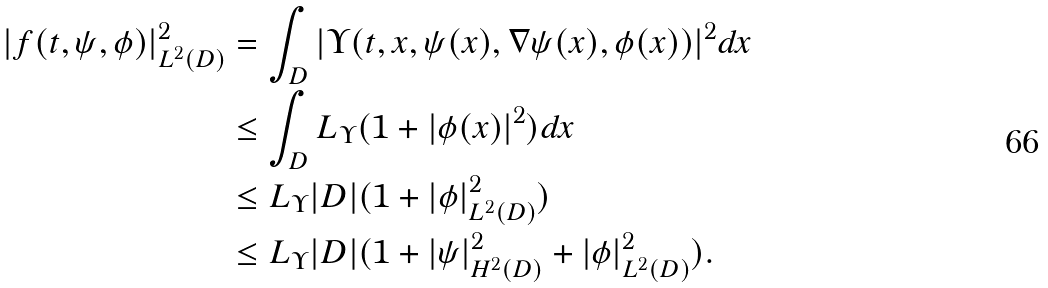<formula> <loc_0><loc_0><loc_500><loc_500>| f ( t , \psi , \phi ) | ^ { 2 } _ { L ^ { 2 } ( D ) } & = \int _ { D } | \Upsilon ( t , x , \psi ( x ) , \nabla \psi ( x ) , \phi ( x ) ) | ^ { 2 } d x \\ & \leq \int _ { D } L _ { \Upsilon } ( 1 + | \phi ( x ) | ^ { 2 } ) d x \\ & \leq L _ { \Upsilon } | D | ( 1 + | \phi | ^ { 2 } _ { L ^ { 2 } ( D ) } ) \\ & \leq L _ { \Upsilon } | D | ( 1 + | \psi | ^ { 2 } _ { H ^ { 2 } ( D ) } + | \phi | ^ { 2 } _ { L ^ { 2 } ( D ) } ) .</formula> 